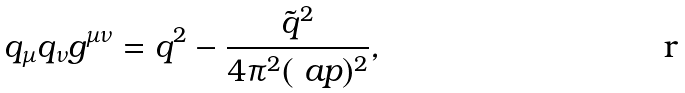Convert formula to latex. <formula><loc_0><loc_0><loc_500><loc_500>q _ { \mu } q _ { \nu } g ^ { \mu \nu } = q ^ { 2 } - \frac { \tilde { q } ^ { 2 } } { 4 \pi ^ { 2 } ( \ a p ) ^ { 2 } } ,</formula> 